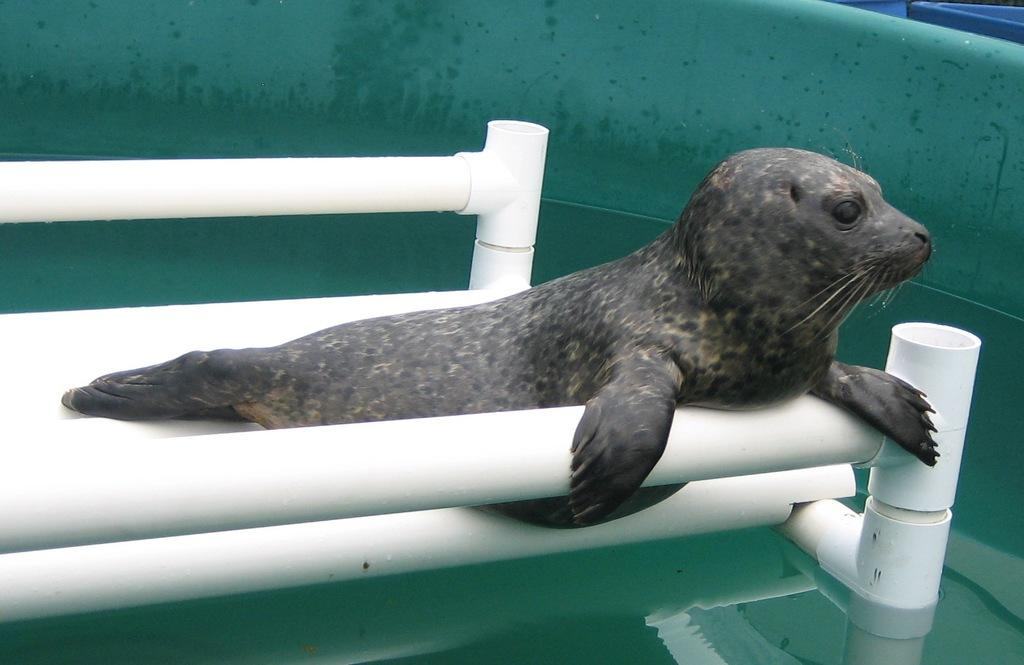What animal is present in the image? There is a seal in the image. Where is the seal located? The seal is in a tub of water. What else can be seen in the image besides the seal? There are white pipes in the image. How many crates of apples are visible in the image? There are no crates of apples present in the image. What type of pollution can be seen in the image? There is no pollution visible in the image. 